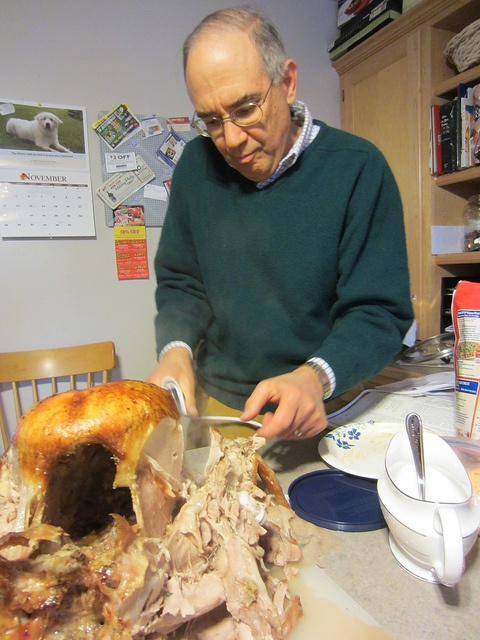Describe the objects in this image and their specific colors. I can see people in gray, teal, black, and tan tones, dining table in gray, tan, and darkgray tones, chair in gray, tan, and darkgray tones, bowl in gray, ivory, beige, and darkgray tones, and dog in gray and darkgray tones in this image. 